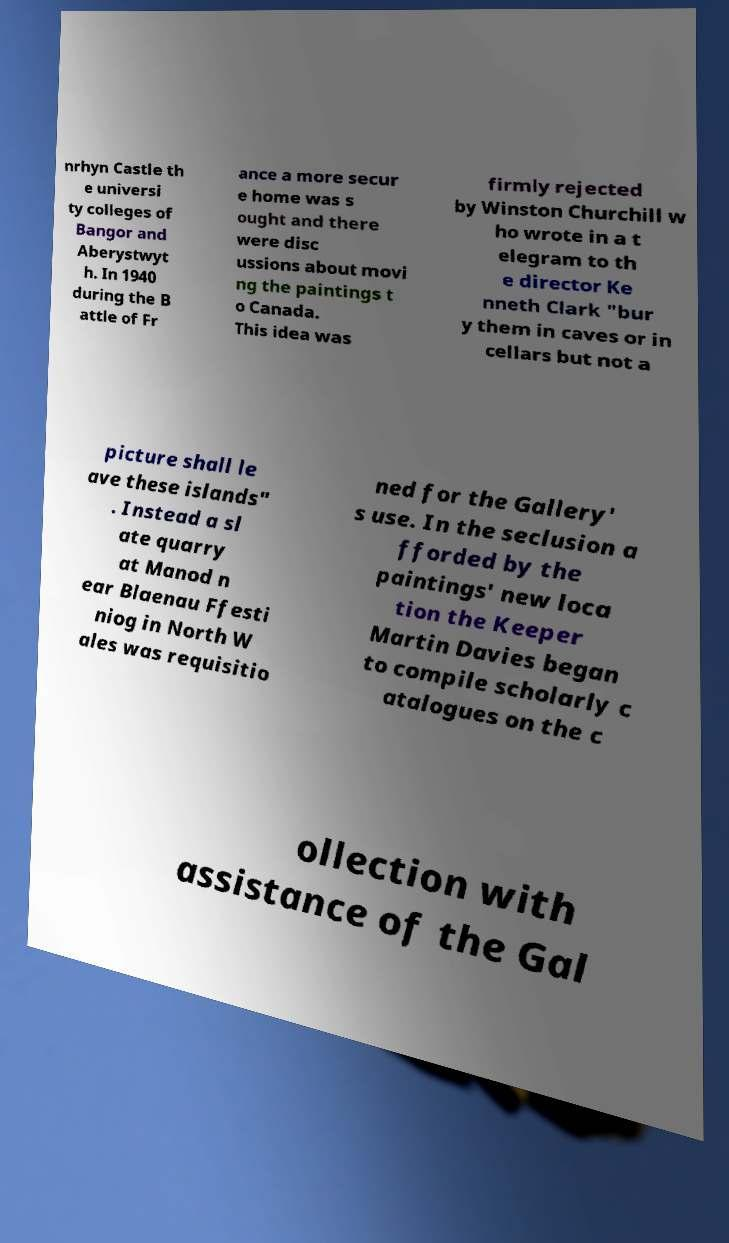What messages or text are displayed in this image? I need them in a readable, typed format. nrhyn Castle th e universi ty colleges of Bangor and Aberystwyt h. In 1940 during the B attle of Fr ance a more secur e home was s ought and there were disc ussions about movi ng the paintings t o Canada. This idea was firmly rejected by Winston Churchill w ho wrote in a t elegram to th e director Ke nneth Clark "bur y them in caves or in cellars but not a picture shall le ave these islands" . Instead a sl ate quarry at Manod n ear Blaenau Ffesti niog in North W ales was requisitio ned for the Gallery' s use. In the seclusion a fforded by the paintings' new loca tion the Keeper Martin Davies began to compile scholarly c atalogues on the c ollection with assistance of the Gal 